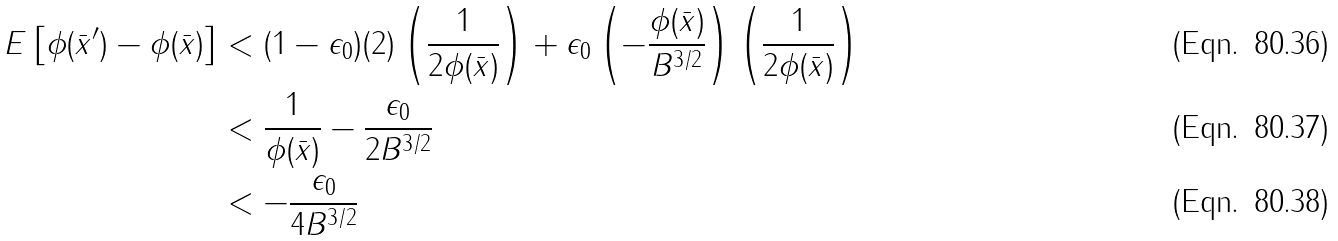Convert formula to latex. <formula><loc_0><loc_0><loc_500><loc_500>E \left [ \phi ( \bar { x } ^ { \prime } ) - \phi ( \bar { x } ) \right ] & < ( 1 - \epsilon _ { 0 } ) ( 2 ) \left ( \frac { 1 } { 2 \phi ( \bar { x } ) } \right ) + \epsilon _ { 0 } \left ( - \frac { \phi ( \bar { x } ) } { B ^ { 3 / 2 } } \right ) \left ( \frac { 1 } { 2 \phi ( \bar { x } ) } \right ) \\ & < \frac { 1 } { \phi ( \bar { x } ) } - \frac { \epsilon _ { 0 } } { 2 B ^ { 3 / 2 } } \\ & < - \frac { \epsilon _ { 0 } } { 4 B ^ { 3 / 2 } }</formula> 